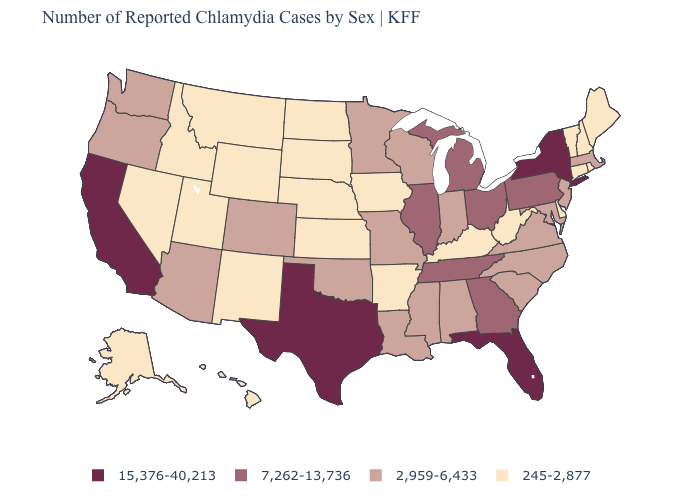Is the legend a continuous bar?
Be succinct. No. What is the lowest value in the USA?
Be succinct. 245-2,877. Which states hav the highest value in the Northeast?
Be succinct. New York. What is the highest value in states that border Connecticut?
Concise answer only. 15,376-40,213. How many symbols are there in the legend?
Give a very brief answer. 4. Does the map have missing data?
Be succinct. No. Among the states that border South Dakota , which have the lowest value?
Give a very brief answer. Iowa, Montana, Nebraska, North Dakota, Wyoming. What is the value of Colorado?
Keep it brief. 2,959-6,433. Name the states that have a value in the range 245-2,877?
Give a very brief answer. Alaska, Arkansas, Connecticut, Delaware, Hawaii, Idaho, Iowa, Kansas, Kentucky, Maine, Montana, Nebraska, Nevada, New Hampshire, New Mexico, North Dakota, Rhode Island, South Dakota, Utah, Vermont, West Virginia, Wyoming. What is the lowest value in the USA?
Write a very short answer. 245-2,877. Which states have the highest value in the USA?
Quick response, please. California, Florida, New York, Texas. What is the value of Ohio?
Write a very short answer. 7,262-13,736. What is the highest value in the USA?
Quick response, please. 15,376-40,213. Name the states that have a value in the range 15,376-40,213?
Answer briefly. California, Florida, New York, Texas. 